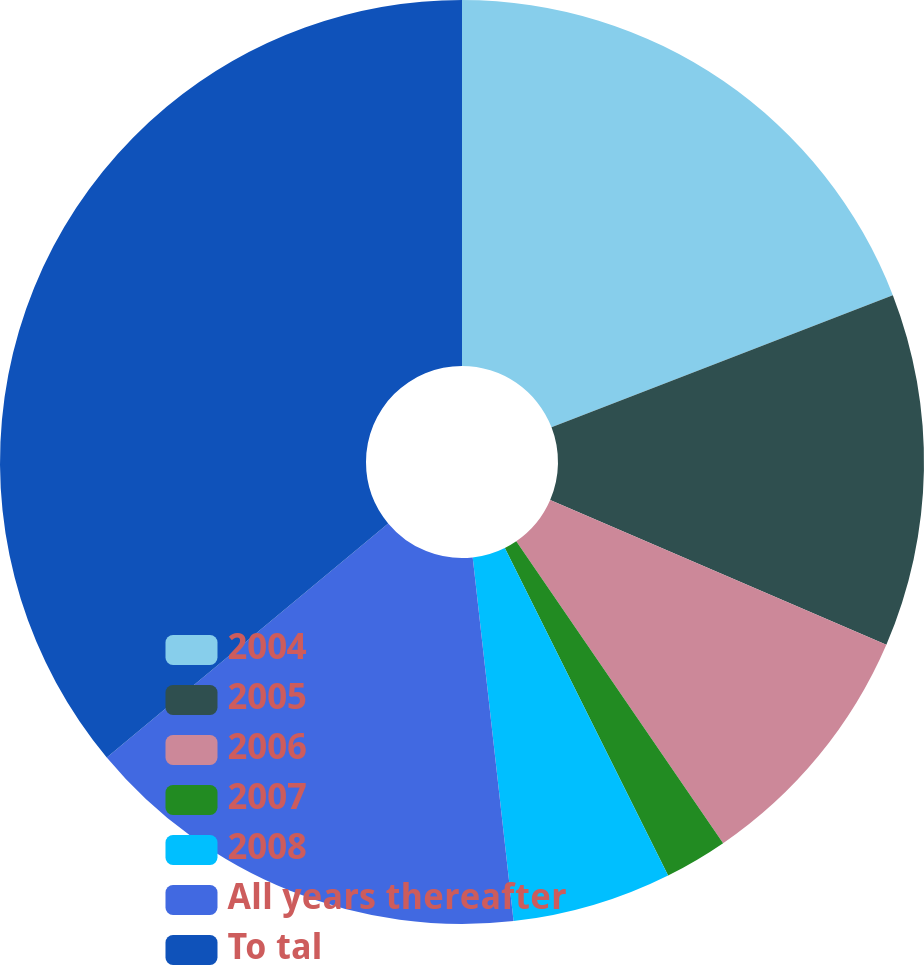Convert chart to OTSL. <chart><loc_0><loc_0><loc_500><loc_500><pie_chart><fcel>2004<fcel>2005<fcel>2006<fcel>2007<fcel>2008<fcel>All years thereafter<fcel>To tal<nl><fcel>19.12%<fcel>12.35%<fcel>8.97%<fcel>2.2%<fcel>5.58%<fcel>15.74%<fcel>36.04%<nl></chart> 